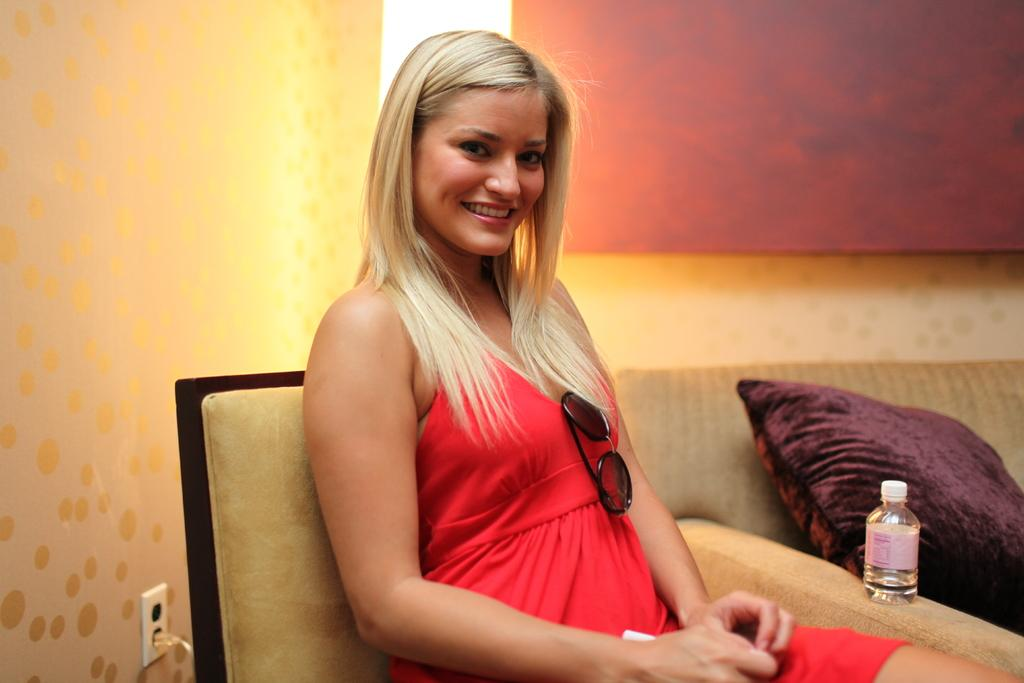Who is present in the image? There is a woman in the image. What is the woman doing in the image? The woman is sitting on a chair and smiling. What other furniture is visible in the image? There is a sofa with a pillow on it in the image. What can be seen in the background of the image? There is a wall visible in the background of the image. What type of beetle can be seen crawling on the woman's shoulder in the image? There is no beetle present on the woman's shoulder in the image. What is the reason for the woman's smile in the image? The reason for the woman's smile cannot be determined from the image alone. 